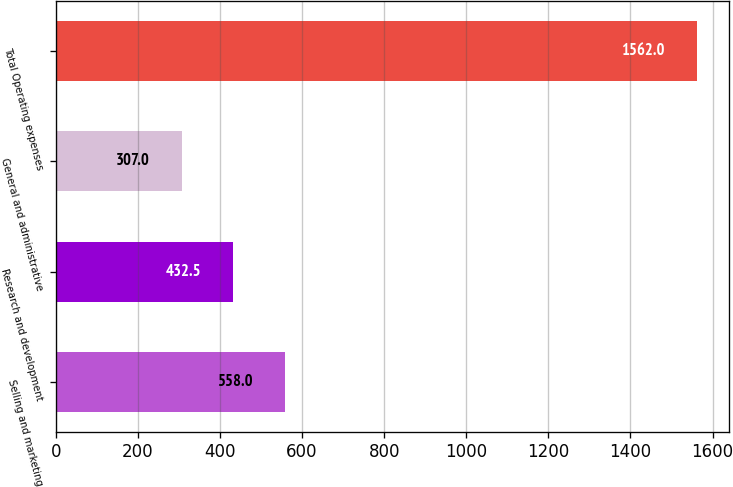Convert chart. <chart><loc_0><loc_0><loc_500><loc_500><bar_chart><fcel>Selling and marketing<fcel>Research and development<fcel>General and administrative<fcel>Total Operating expenses<nl><fcel>558<fcel>432.5<fcel>307<fcel>1562<nl></chart> 